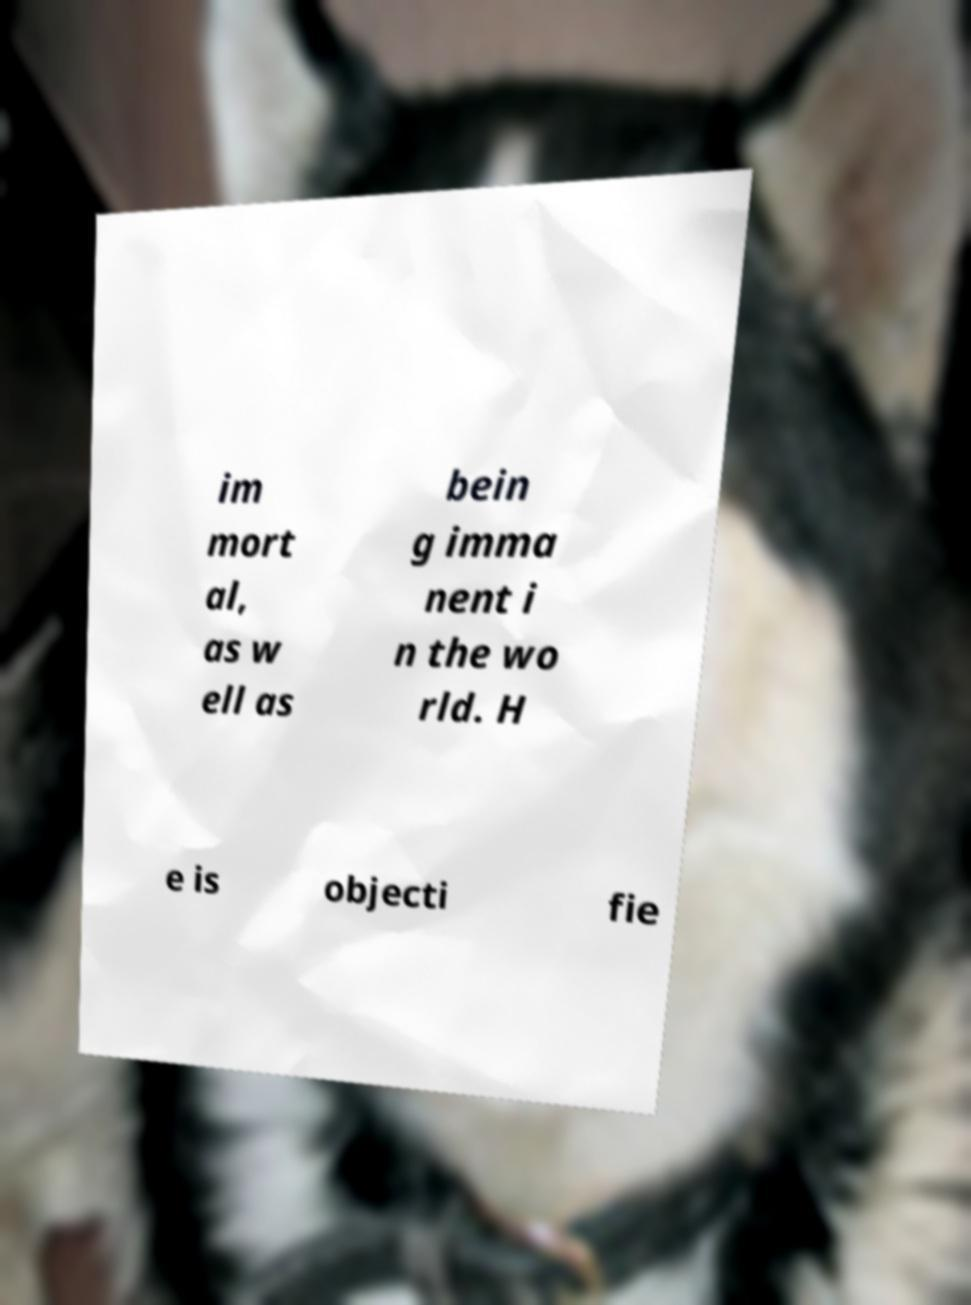Please read and relay the text visible in this image. What does it say? im mort al, as w ell as bein g imma nent i n the wo rld. H e is objecti fie 